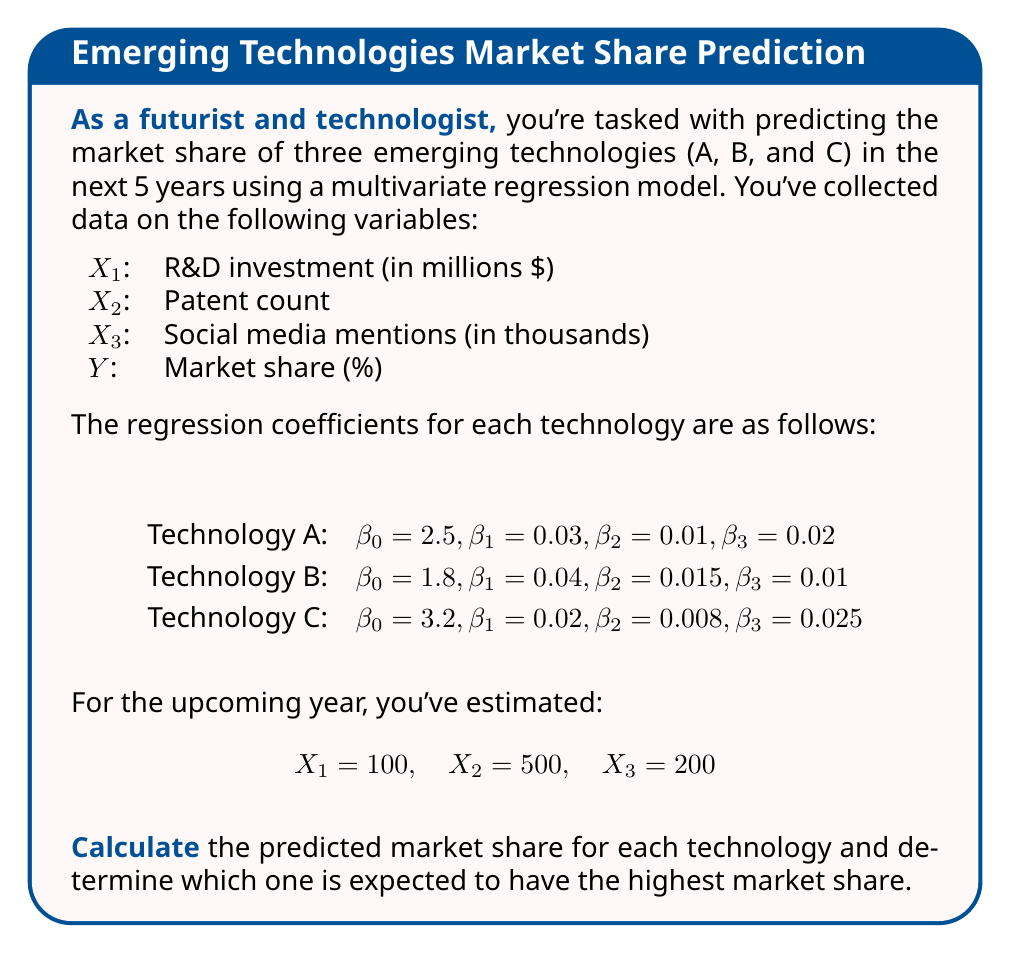Can you answer this question? To solve this problem, we'll use the multivariate regression model for each technology:

$$ Y = \beta_0 + \beta_1X_1 + \beta_2X_2 + \beta_3X_3 $$

Where Y is the predicted market share, β0 is the intercept, and β1, β2, β3 are the coefficients for X1, X2, and X3 respectively.

Let's calculate the predicted market share for each technology:

1. Technology A:
$$ Y_A = 2.5 + 0.03(100) + 0.01(500) + 0.02(200) $$
$$ Y_A = 2.5 + 3 + 5 + 4 = 14.5\% $$

2. Technology B:
$$ Y_B = 1.8 + 0.04(100) + 0.015(500) + 0.01(200) $$
$$ Y_B = 1.8 + 4 + 7.5 + 2 = 15.3\% $$

3. Technology C:
$$ Y_C = 3.2 + 0.02(100) + 0.008(500) + 0.025(200) $$
$$ Y_C = 3.2 + 2 + 4 + 5 = 14.2\% $$

Comparing the results:
Technology A: 14.5%
Technology B: 15.3%
Technology C: 14.2%

Therefore, Technology B is expected to have the highest market share at 15.3%.
Answer: Technology B, 15.3% 